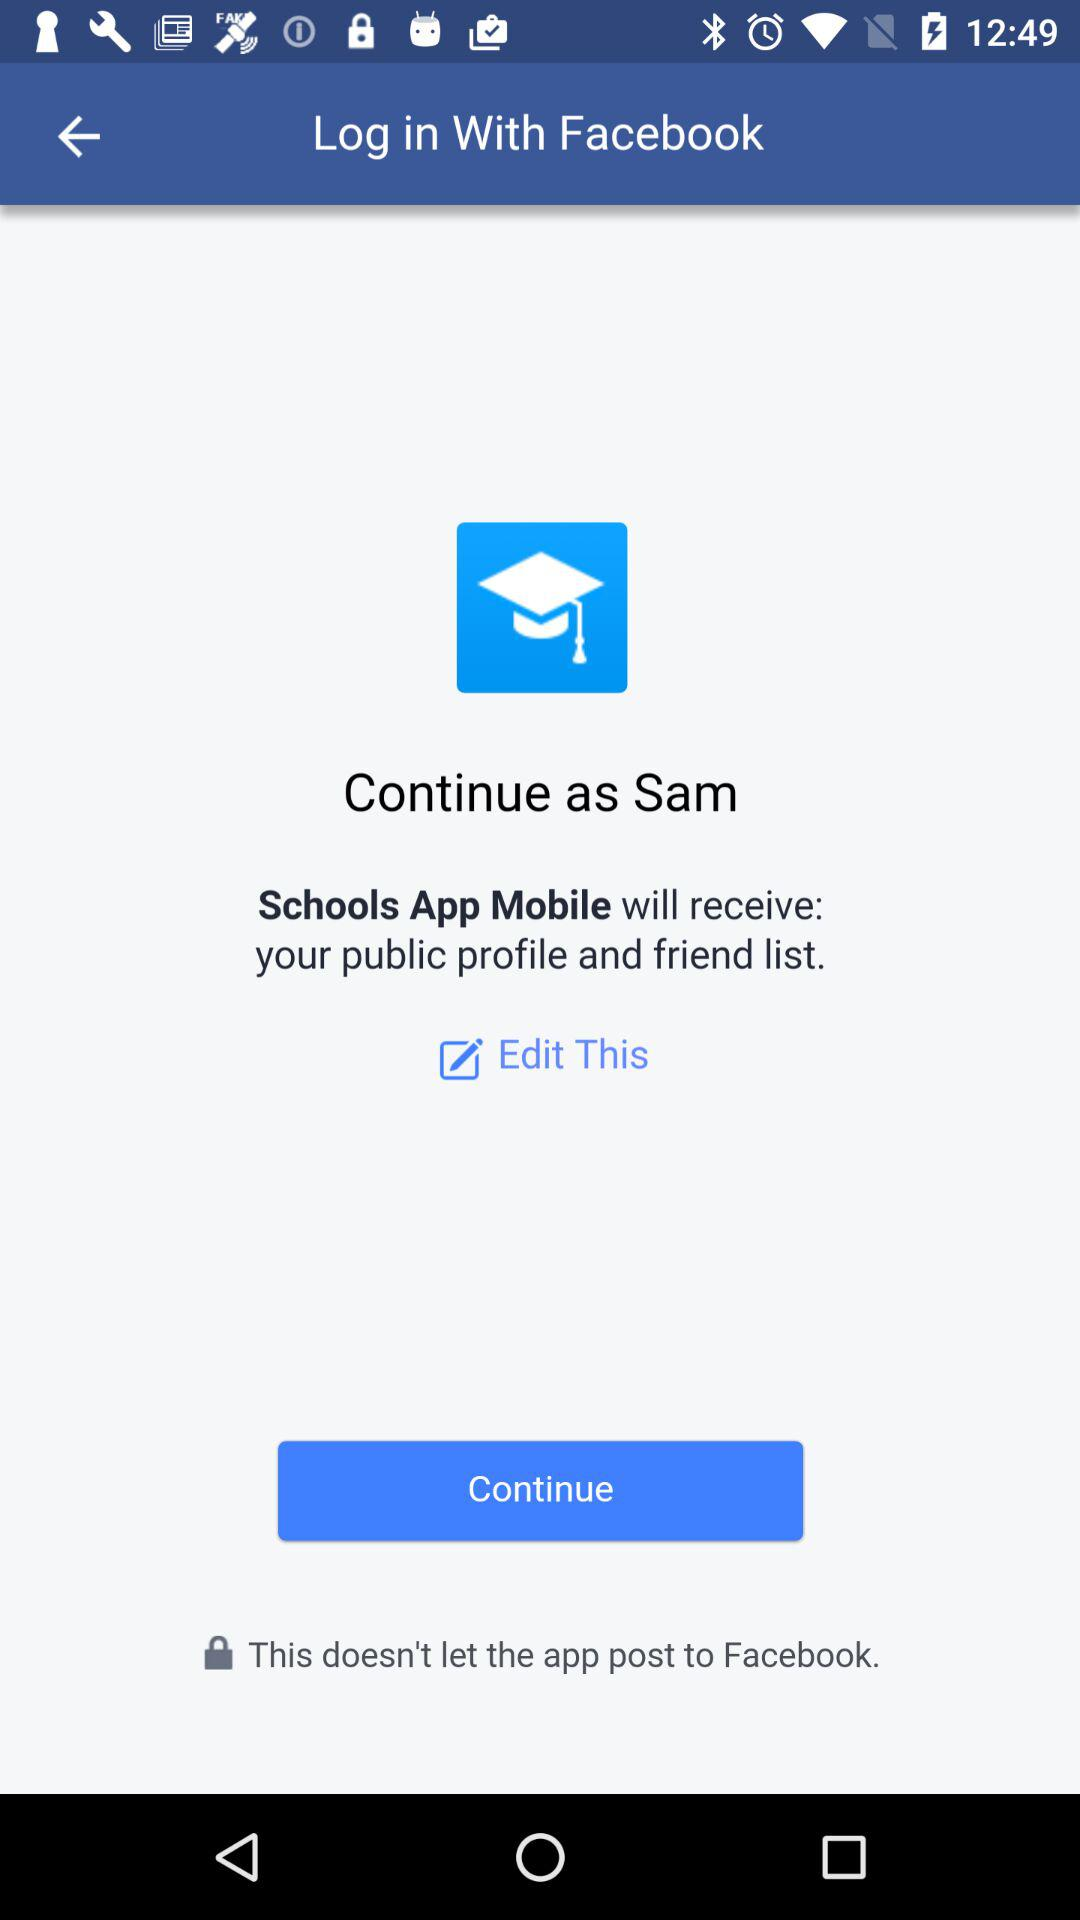Through what application can we log in? You can log in through "Facebook". 